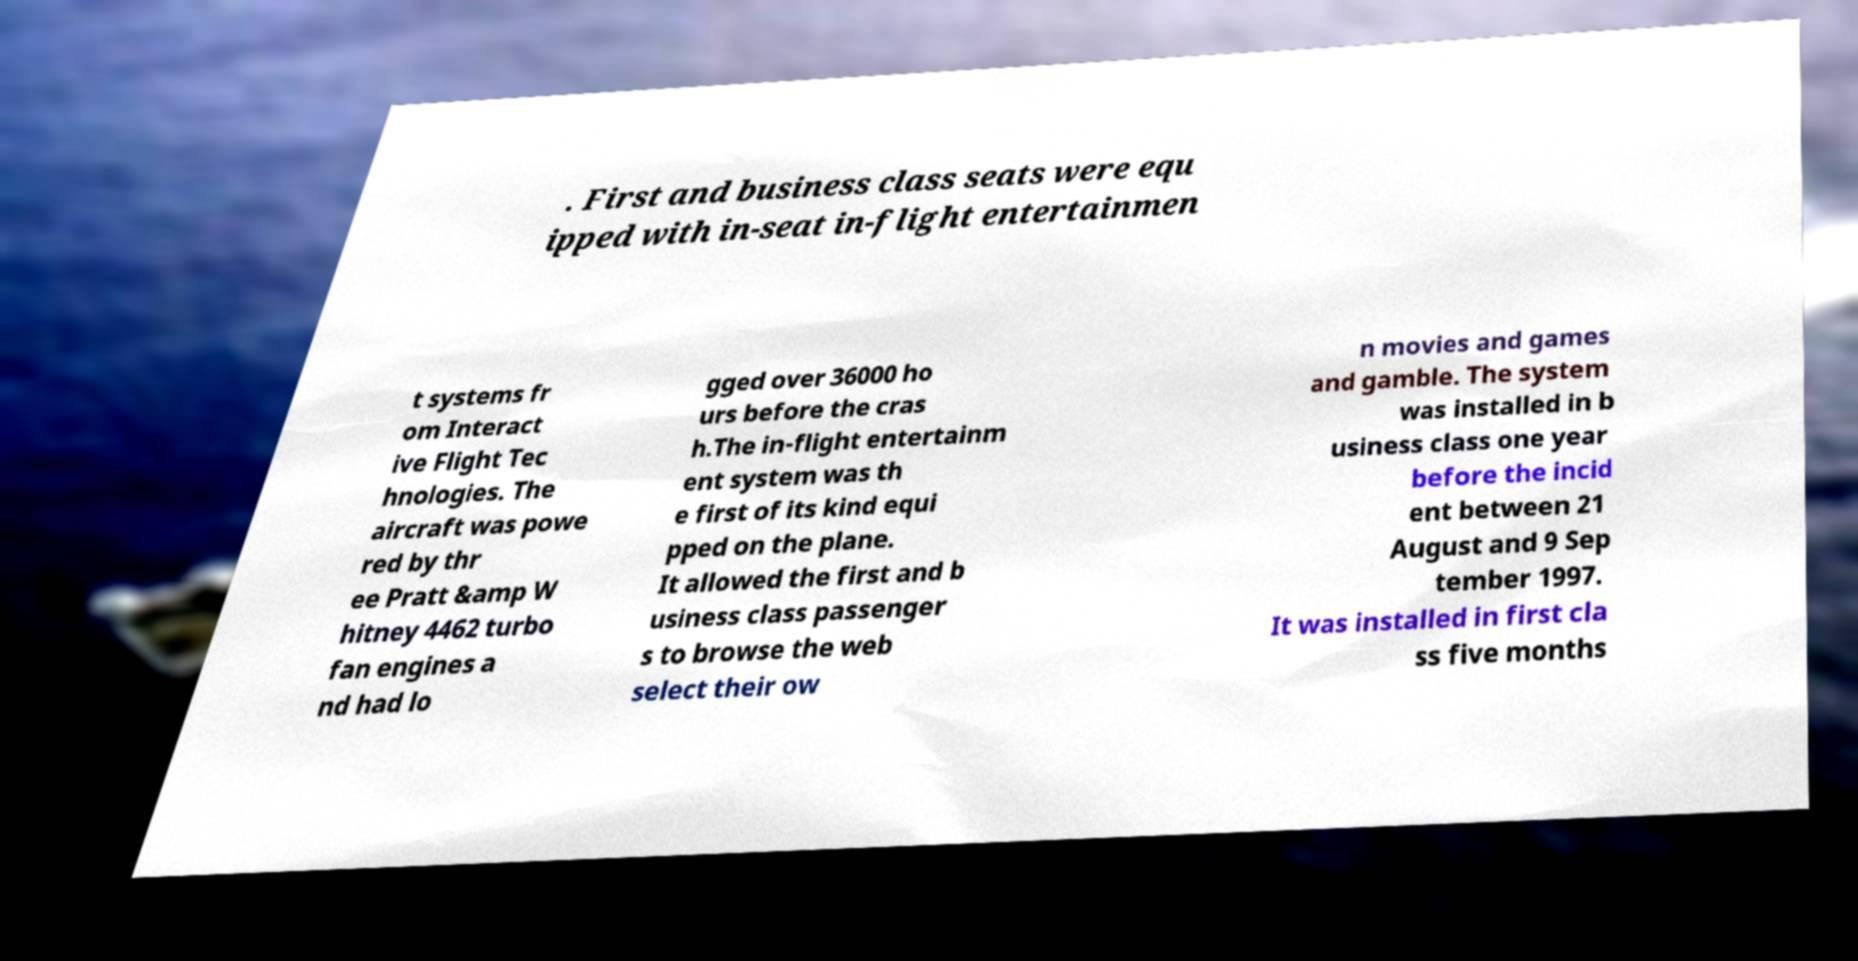Please identify and transcribe the text found in this image. . First and business class seats were equ ipped with in-seat in-flight entertainmen t systems fr om Interact ive Flight Tec hnologies. The aircraft was powe red by thr ee Pratt &amp W hitney 4462 turbo fan engines a nd had lo gged over 36000 ho urs before the cras h.The in-flight entertainm ent system was th e first of its kind equi pped on the plane. It allowed the first and b usiness class passenger s to browse the web select their ow n movies and games and gamble. The system was installed in b usiness class one year before the incid ent between 21 August and 9 Sep tember 1997. It was installed in first cla ss five months 